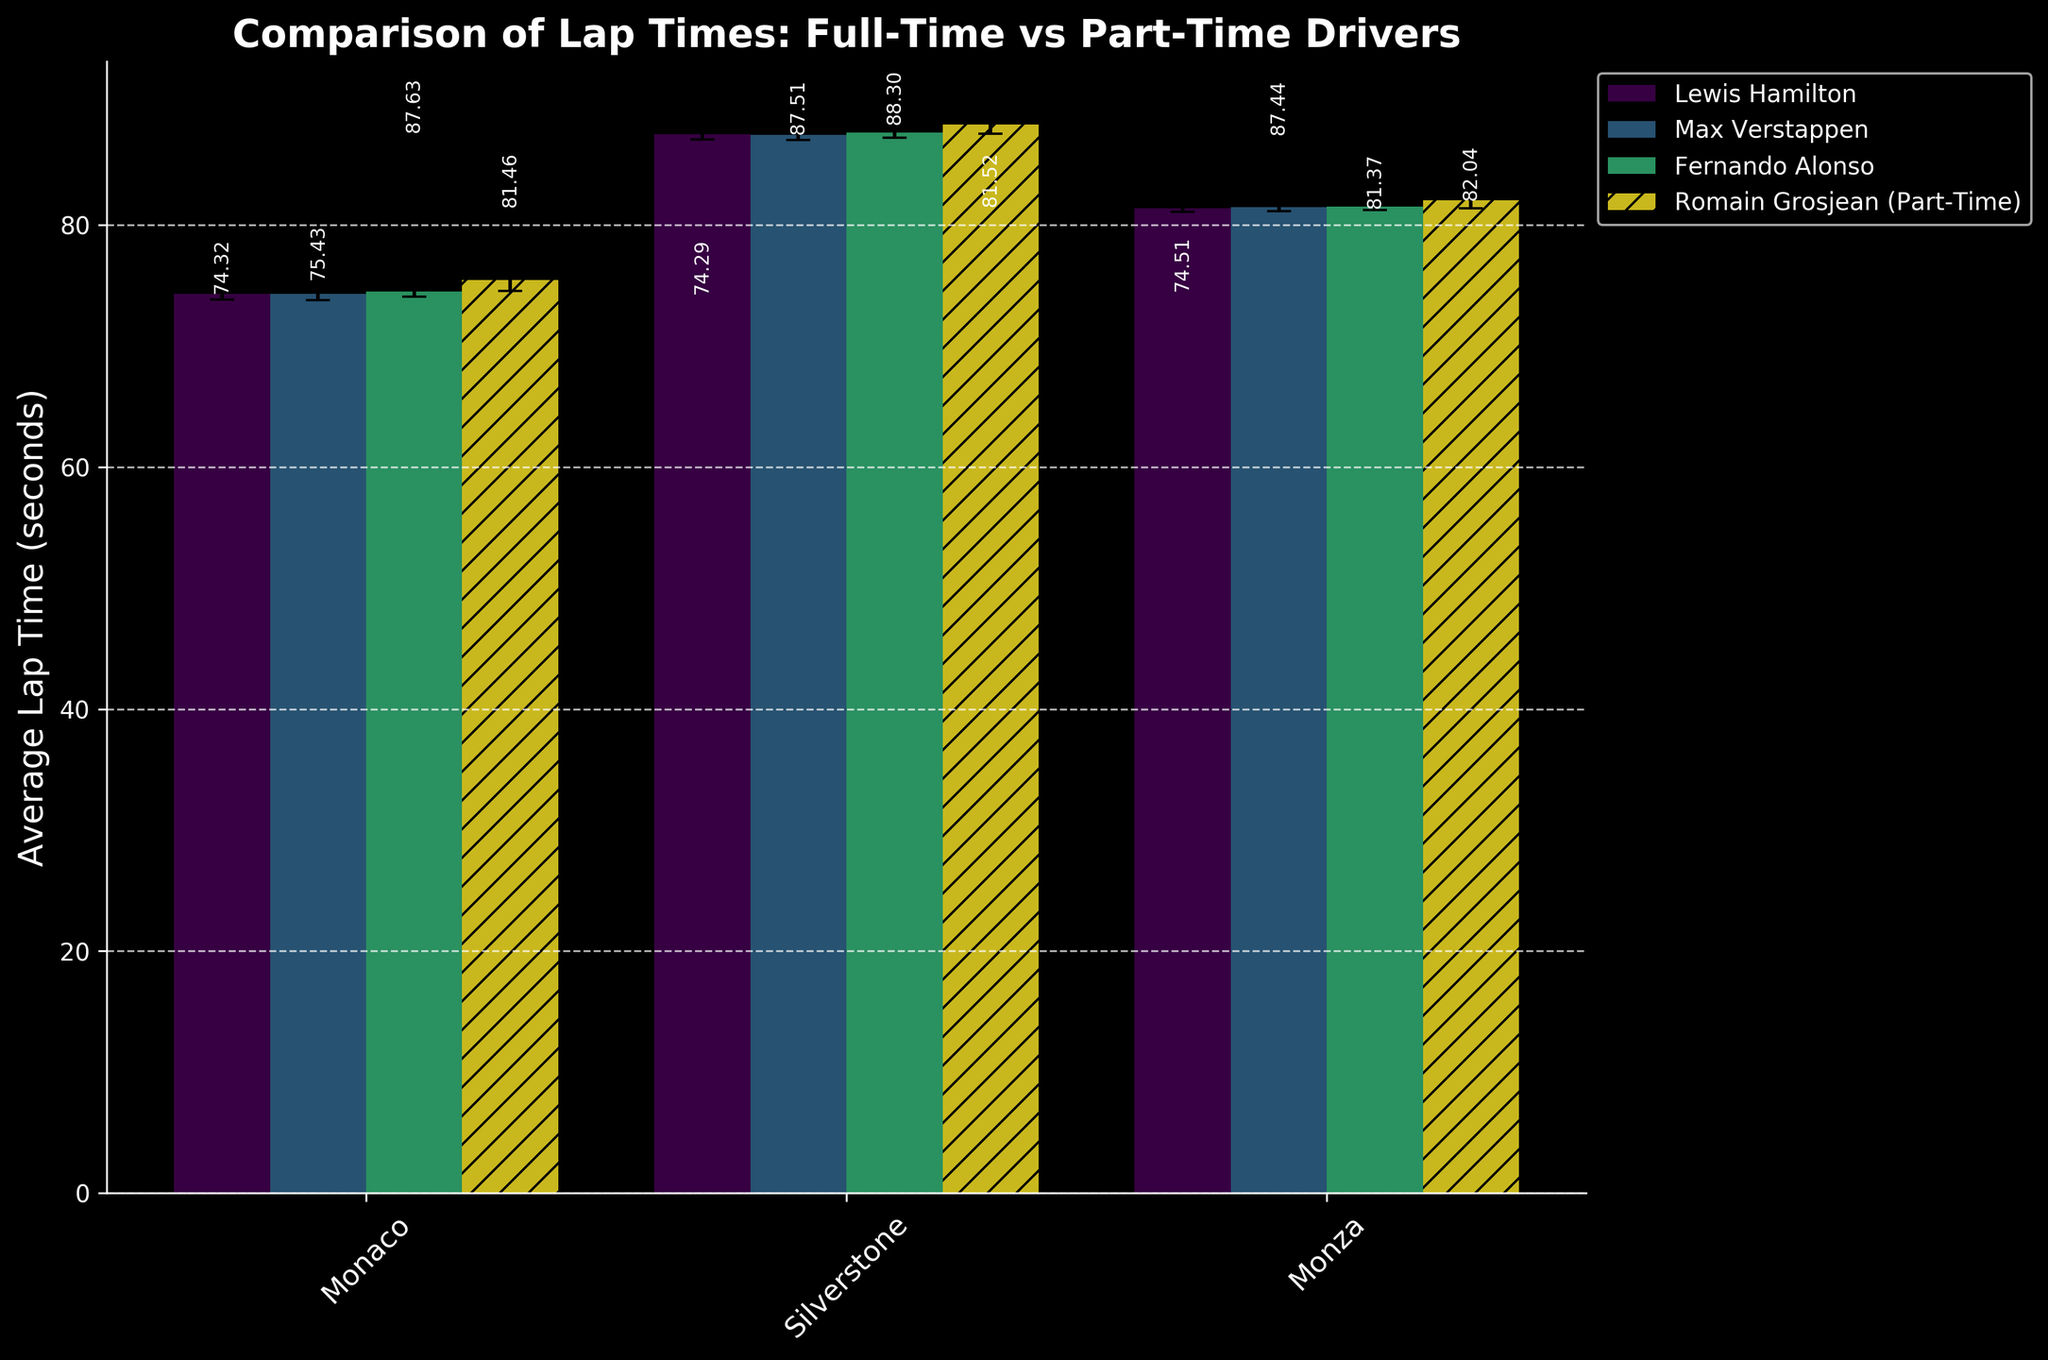What is the title of the plot? The title is usually found at the top of the plot. For this plot, the title is "Comparison of Lap Times: Full-Time vs Part-Time Drivers" as specified in the code's `set_title` method.
Answer: Comparison of Lap Times: Full-Time vs Part-Time Drivers Which driver has the highest average lap time at the Monaco race? By examining the bars for Monaco, you can see that Romain Grosjean, a part-time driver, has the highest average lap time at about 75.432 seconds.
Answer: Romain Grosjean How do the error bars for Lewis Hamilton and Romain Grosjean compare at Monza? Error bars indicate the standard deviation. For Monza, the error bars for Lewis Hamilton are very short, indicating a low standard deviation. In contrast, Romain Grosjean’s error bars are much longer, showing greater variability in his lap times.
Answer: Romain Grosjean's error bars are longer Which driver exhibits the least variability in lap times at Silverstone? The driver with the smallest standard deviation has the least variability. At Silverstone, Max Verstappen’s error bar (standard deviation of 0.398 seconds) is the shortest among all drivers.
Answer: Max Verstappen What is the relative difference between the average lap time of full-time and part-time drivers at Monaco? The average lap times at Monaco for full-time drivers (Lewis Hamilton, Max Verstappen, and Fernando Alonso) are around 74.321, 74.293, and 74.512 seconds respectively. The part-time driver, Romain Grosjean, has an average lap time of 75.432 seconds. This indicates part-time drivers are roughly 1 second slower. Calculation: 75.432 - Average(74.321, 74.293, 74.512) ≈ 1.035 seconds.
Answer: ≈ 1 second slower Which race shows the smallest difference in average lap times among all drivers? Looking at the variability in bars across all races, Monaco and Silverstone have larger differences; however, Monza shows very closely packed average lap times indicating the smallest difference.
Answer: Monza Between Max Verstappen and Fernando Alonso at Monaco, who is more consistent in lap times? Consistency is indicated by the length of the error bars (standard deviation). At Monaco, Max Verstappen's error bar (0.512 seconds) is slightly longer than Fernando Alonso's (0.432 seconds), indicating Alonso is more consistent.
Answer: Fernando Alonso 